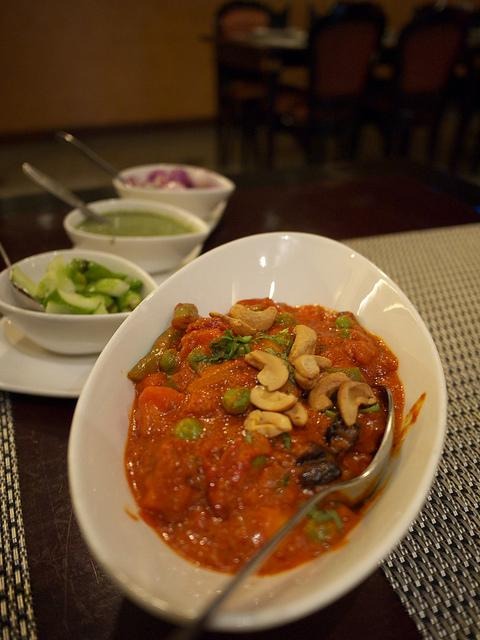What fungal growth is visible here?

Choices:
A) tomatoes
B) mushrooms
C) cucumbers
D) olives mushrooms 